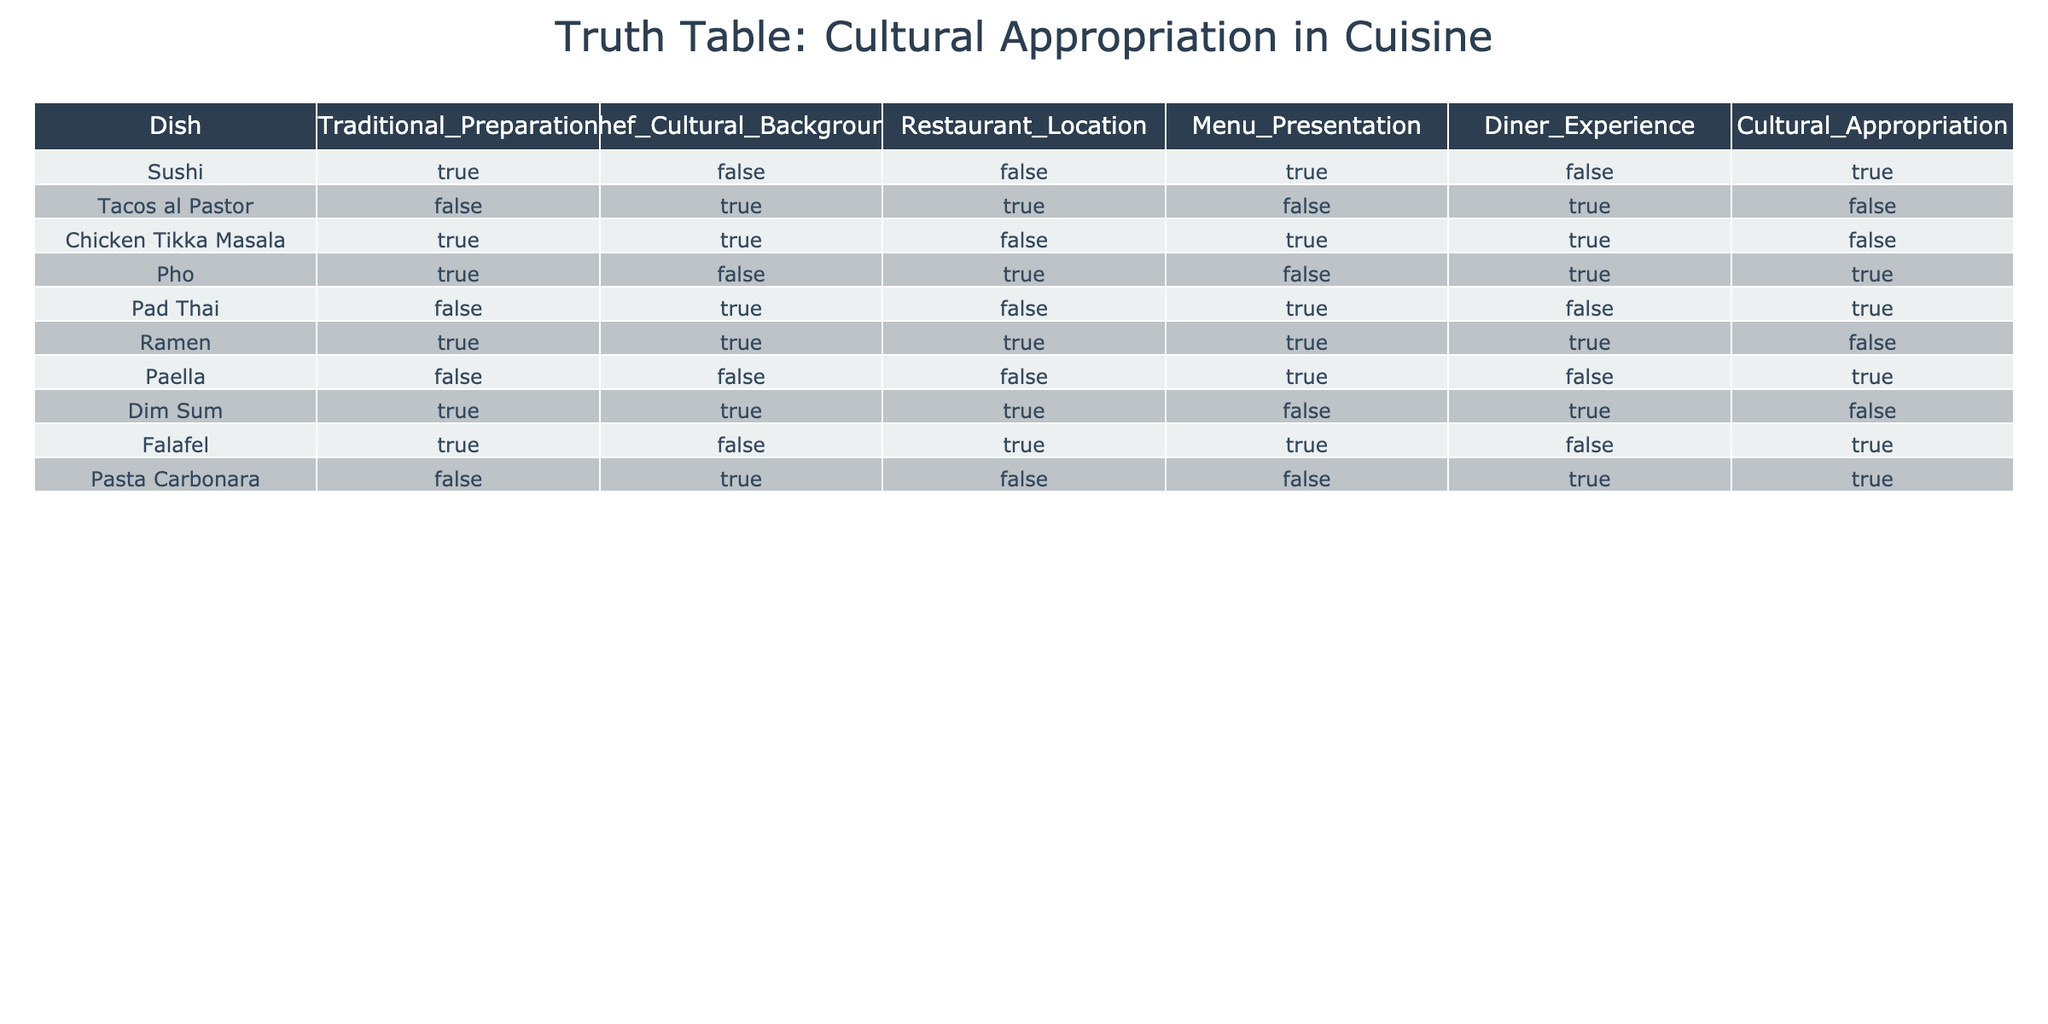What dish has the highest indication of cultural appropriation? By analyzing the "Cultural_Appropriation" column, the dish with the most "TRUE" values for cultural appropriation is Sushi, as it is the only one with that status in isolation.
Answer: Sushi Is Chicken Tikka Masala prepared traditionally? Looking at the "Traditional_Preparation" column, Chicken Tikka Masala has a value of TRUE, indicating that it is prepared traditionally.
Answer: Yes How many dishes are served in locations outside their traditional cultural background? In the "Chef_Cultural_Background" and "Restaurant_Location" columns, we can see that Tacos al Pastor, Pho, Pad Thai, and Falafel are served outside their traditional backgrounds. Specifically, Tacos al Pastor and Pho are marked TRUE in location, leading to a total of 4 dishes being outside their traditional setting.
Answer: 4 Does Dim Sum indicate cultural appropriation? The "Cultural_Appropriation" column indicates that Dim Sum is marked FALSE, meaning it does not indicate cultural appropriation.
Answer: No Which dishes are both traditional and not culturally appropriated? By looking at both "Traditional_Preparation" and "Cultural_Appropriation" columns, Chicken Tikka Masala and Ramen are traditional and marked FALSE under Cultural Appropriation.
Answer: Chicken Tikka Masala, Ramen What is the ratio of dishes that are not traditionally prepared to those that are? In total, 5 dishes are not traditionally prepared: Tacos al Pastor, Pad Thai, Paella, Pasta Carbonara, and Falafel, while 5 dishes are traditionally prepared. Therefore, the ratio of not traditionally prepared dishes to traditionally prepared is 5:5, which simplifies to 1:1.
Answer: 1:1 How many dishes provide a good diner experience while being culturally appropriated? Examining the "Diner_Experience" column alongside the "Cultural_Appropriation" column shows that the only dish marked TRUE in Diner Experience and TRUE in Cultural Appropriation is Sushi, giving us a total of 1 dish fitting that criterion.
Answer: 1 Are any dishes both culturally appropriated and prepared traditionally? No dishes are marked TRUE under both "Cultural_Appropriation" and "Traditional_Preparation." Thus, the answer is no, indicating that none meet both criteria.
Answer: No 